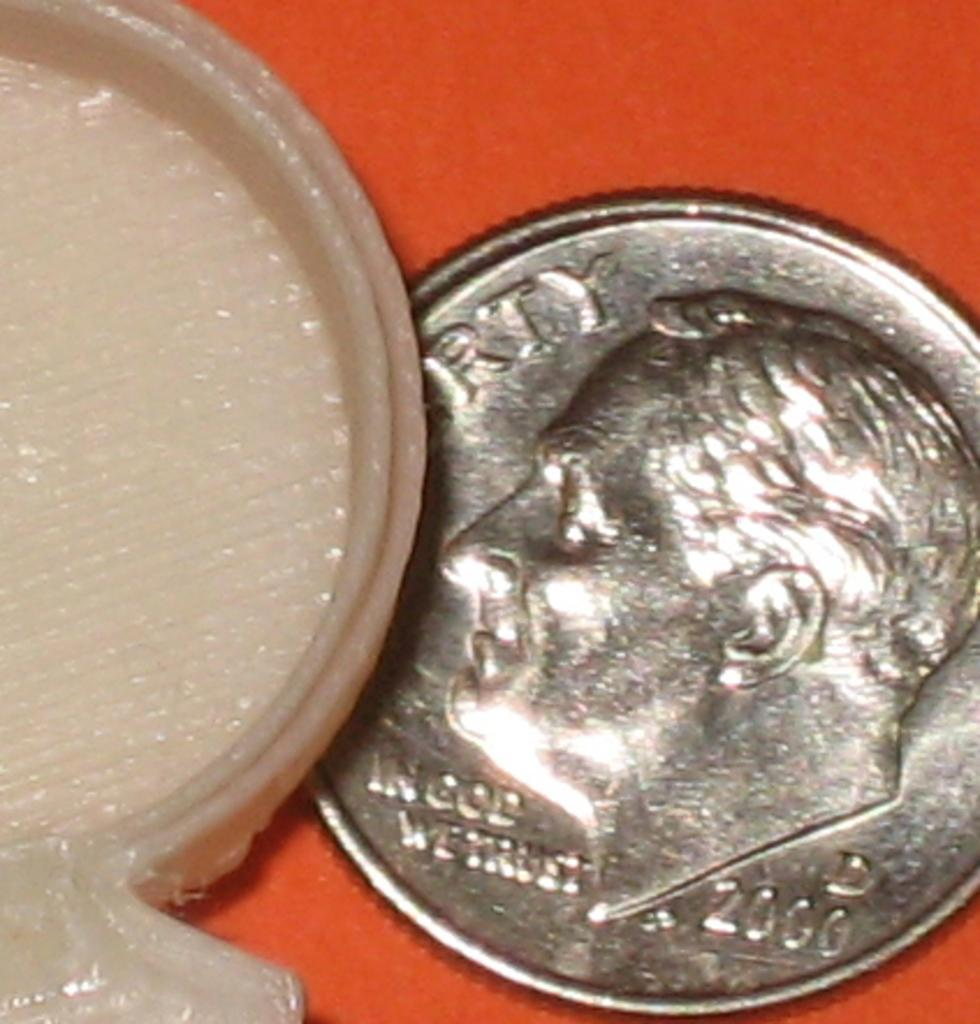Provide a one-sentence caption for the provided image. A dime from 2000 that says Liberty on a red table. 